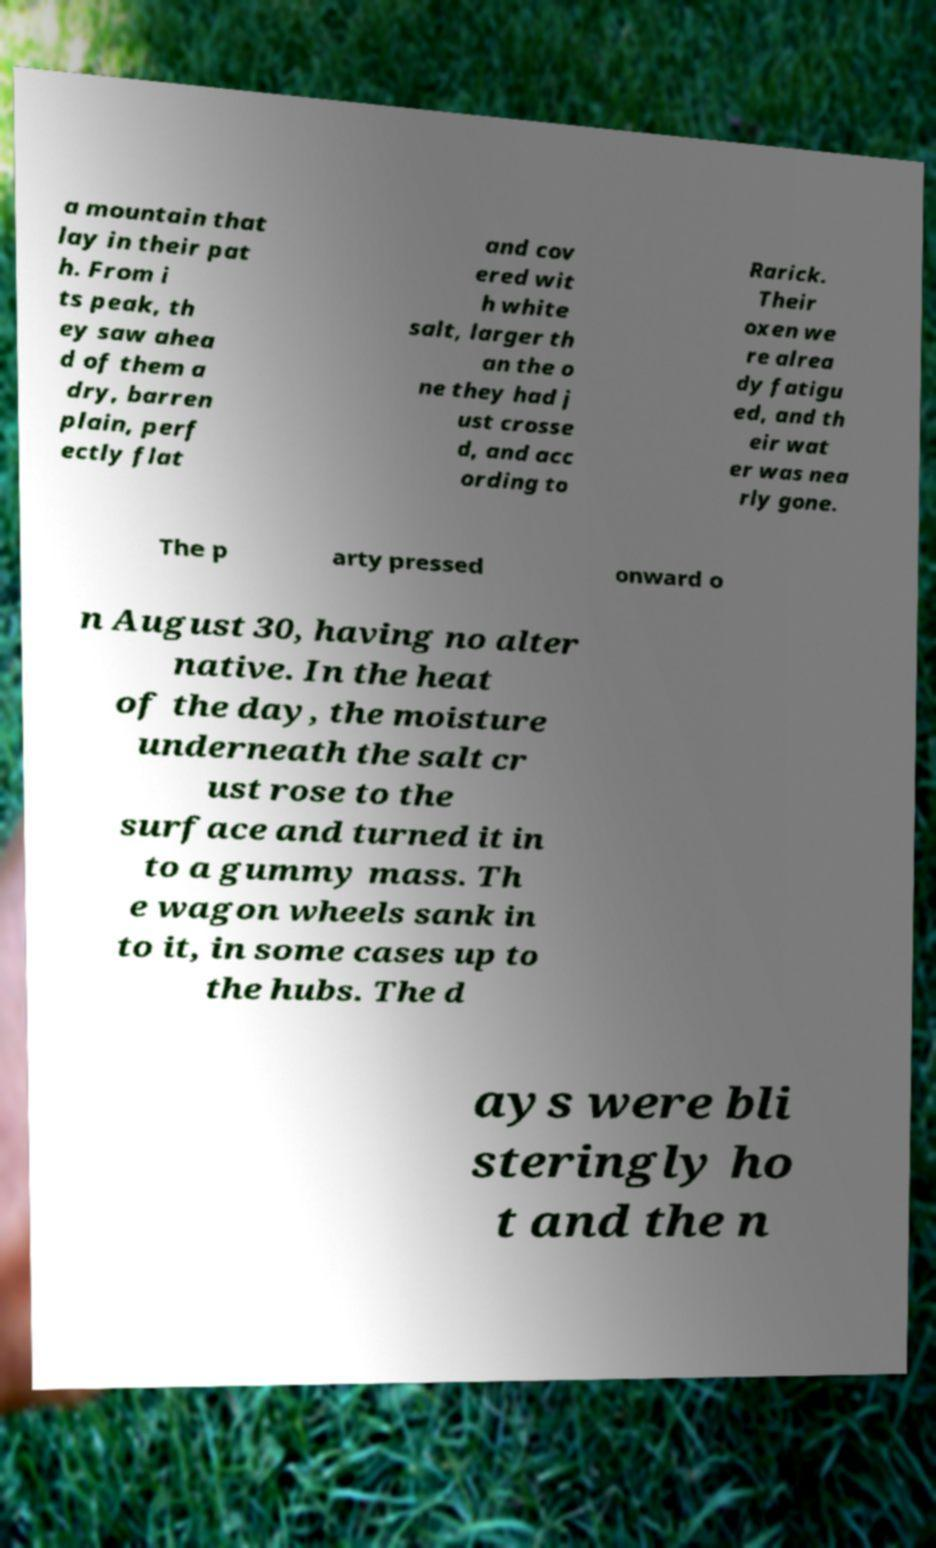Can you read and provide the text displayed in the image?This photo seems to have some interesting text. Can you extract and type it out for me? a mountain that lay in their pat h. From i ts peak, th ey saw ahea d of them a dry, barren plain, perf ectly flat and cov ered wit h white salt, larger th an the o ne they had j ust crosse d, and acc ording to Rarick. Their oxen we re alrea dy fatigu ed, and th eir wat er was nea rly gone. The p arty pressed onward o n August 30, having no alter native. In the heat of the day, the moisture underneath the salt cr ust rose to the surface and turned it in to a gummy mass. Th e wagon wheels sank in to it, in some cases up to the hubs. The d ays were bli steringly ho t and the n 